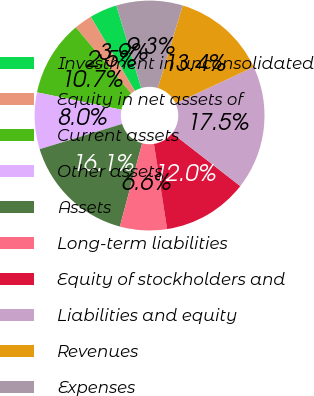Convert chart. <chart><loc_0><loc_0><loc_500><loc_500><pie_chart><fcel>Investment in unconsolidated<fcel>Equity in net assets of<fcel>Current assets<fcel>Other assets<fcel>Assets<fcel>Long-term liabilities<fcel>Equity of stockholders and<fcel>Liabilities and equity<fcel>Revenues<fcel>Expenses<nl><fcel>3.89%<fcel>2.53%<fcel>10.68%<fcel>7.96%<fcel>16.11%<fcel>6.6%<fcel>12.04%<fcel>17.47%<fcel>13.4%<fcel>9.32%<nl></chart> 